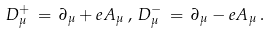Convert formula to latex. <formula><loc_0><loc_0><loc_500><loc_500>D _ { \mu } ^ { + } \, = \, \partial _ { \mu } + e A _ { \mu } \, , \, D _ { \mu } ^ { - } \, = \, \partial _ { \mu } - e A _ { \mu } \, .</formula> 